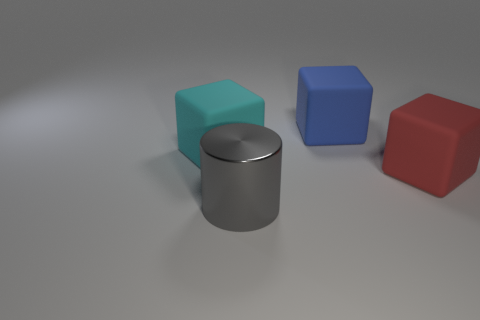Add 3 cyan rubber cubes. How many objects exist? 7 Subtract all blue cubes. How many cubes are left? 2 Subtract 1 cylinders. How many cylinders are left? 0 Subtract all red blocks. How many blocks are left? 2 Subtract all blocks. How many objects are left? 1 Subtract all gray blocks. Subtract all blue balls. How many blocks are left? 3 Subtract all brown balls. How many purple cylinders are left? 0 Subtract all cyan objects. Subtract all blue rubber things. How many objects are left? 2 Add 4 blue cubes. How many blue cubes are left? 5 Add 1 big cubes. How many big cubes exist? 4 